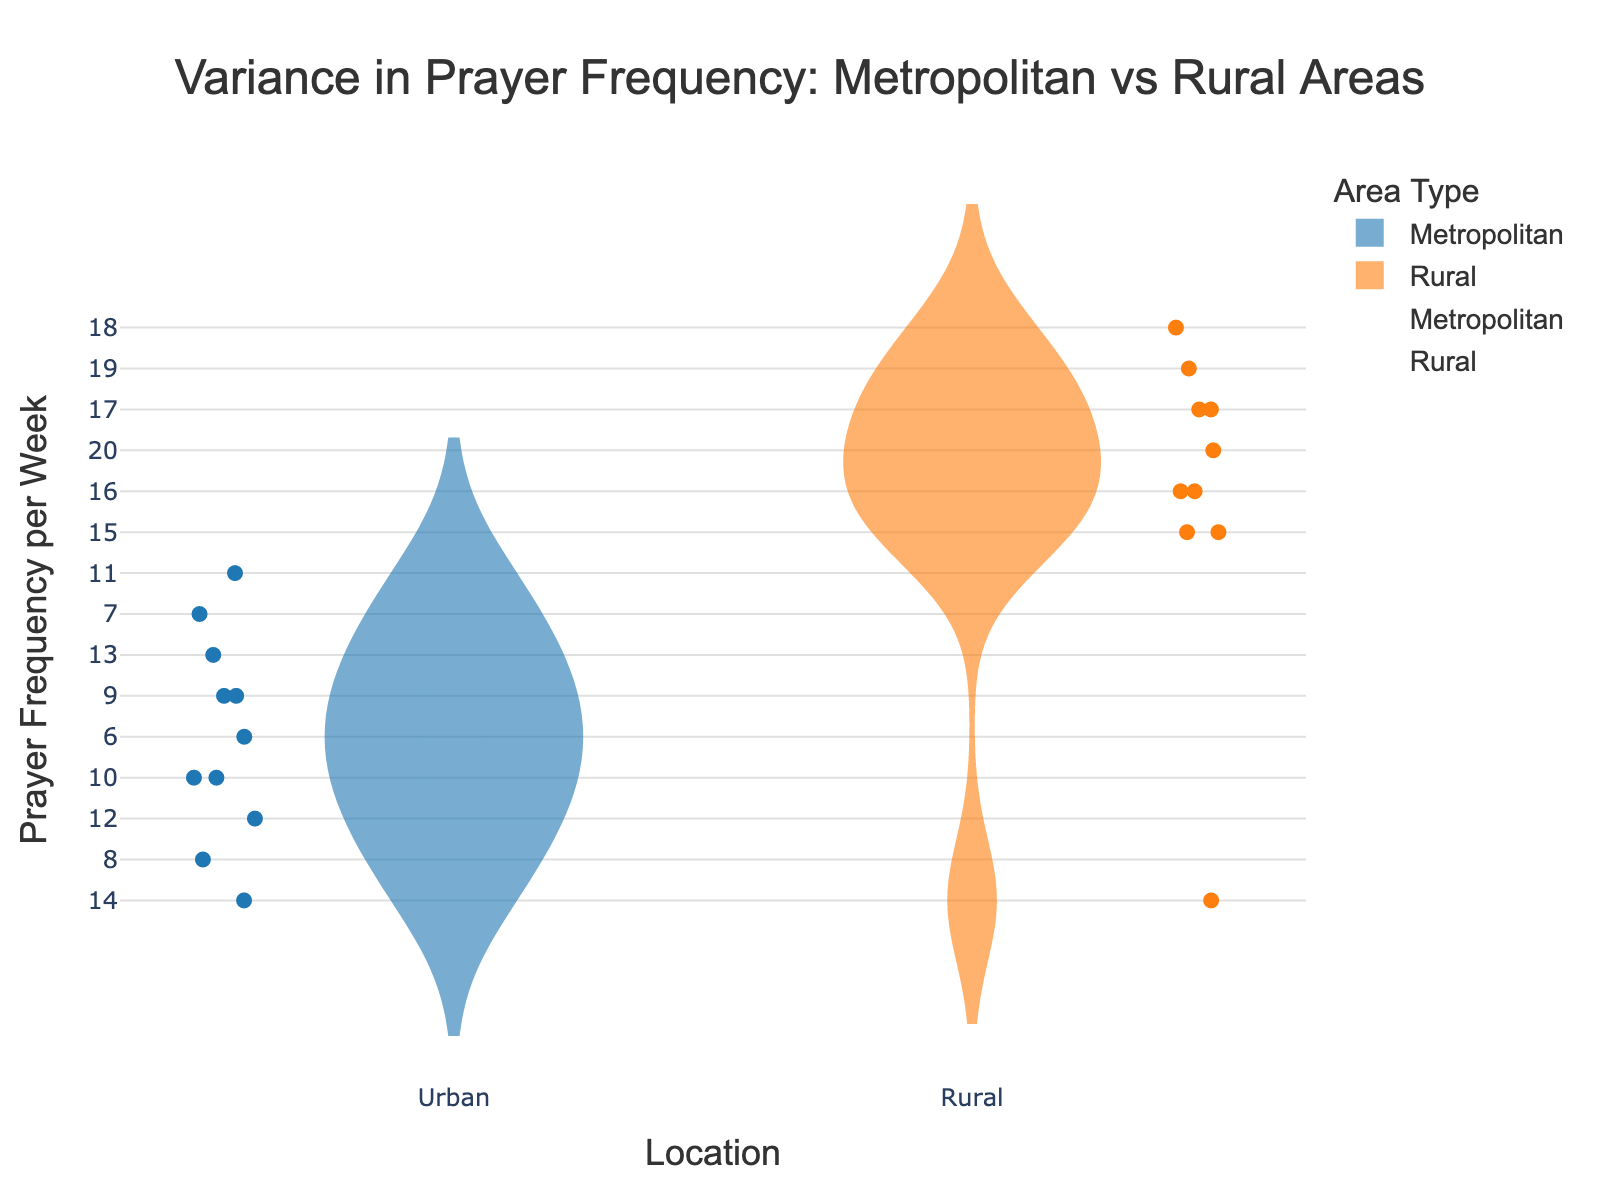What is the title of the figure? The title of the figure is positioned at the top, centrally aligned, indicating the insight the chart is supposed to provide. The title reads "Variance in Prayer Frequency: Metropolitan vs Rural Areas".
Answer: Variance in Prayer Frequency: Metropolitan vs Rural Areas How many points are shown for the metropolitan area? The jittered points are the individual data points visible in the violin plot for the metropolitan area. By counting them, we find there are 11 points.
Answer: 11 What is the color used for the rural area in the plot? The rural area has a specific color attributed to it in both the violin and the jittered points. The color used is a shade of orange.
Answer: Orange What is the median prayer frequency per week in rural areas? The median value can be inferred from the meanline in the violin plot of the rural area data. The box part of the violin plot indicates the median. The median for rural areas is 16.
Answer: 16 Between metropolitan and rural areas, which has the higher average prayer frequency per week? By comparing the meanlines visible in both the metropolitan and rural violin plots, it can be observed that the rural area has a higher average value. The average can be estimated by referencing the box meanline heights.
Answer: Rural What is the range of prayer frequency in the metropolitan area? The range is calculated as the difference between the maximum and minimum values. In the metropolitan area, the minimum value is 6 and the maximum is 14, hence the range is 14 - 6.
Answer: 8 Which location has a wider variance in prayer frequency per week? The variance is visually indicated by the spread of the violin plot. The rural violin plot appears to cover a broader range, suggesting wider variance compared to the metropolitan one.
Answer: Rural Identify the location with the highest prayer frequency per week. Among the jittered points and the violin plots, the highest prayer frequency point is in the rural area with a value of 20, referring to the point in the rural area plot.
Answer: Rural What is the difference between the highest prayer frequency in metropolitan and rural areas? The highest values are 14 for the metropolitan area and 20 for the rural area. The difference can be calculated as 20 - 14.
Answer: 6 